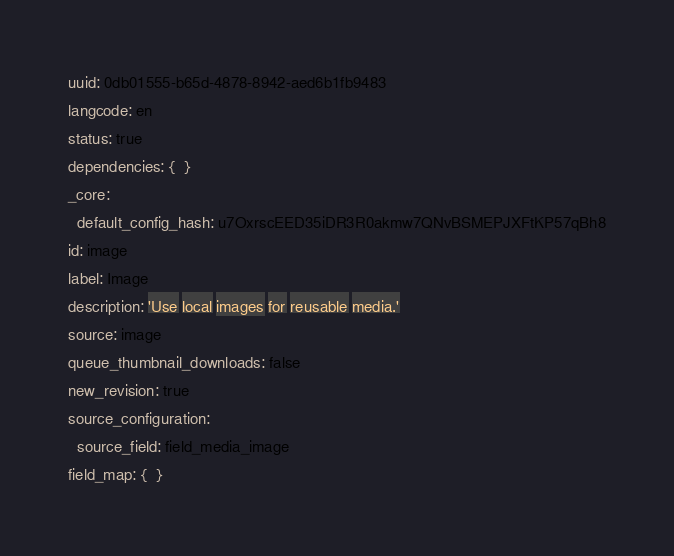Convert code to text. <code><loc_0><loc_0><loc_500><loc_500><_YAML_>uuid: 0db01555-b65d-4878-8942-aed6b1fb9483
langcode: en
status: true
dependencies: {  }
_core:
  default_config_hash: u7OxrscEED35iDR3R0akmw7QNvBSMEPJXFtKP57qBh8
id: image
label: Image
description: 'Use local images for reusable media.'
source: image
queue_thumbnail_downloads: false
new_revision: true
source_configuration:
  source_field: field_media_image
field_map: {  }
</code> 